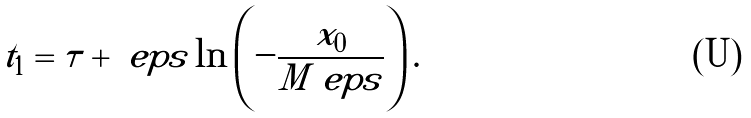Convert formula to latex. <formula><loc_0><loc_0><loc_500><loc_500>t _ { 1 } = \tau + \ e p s \ln \left ( - \frac { x _ { 0 } } { M \ e p s } \right ) .</formula> 